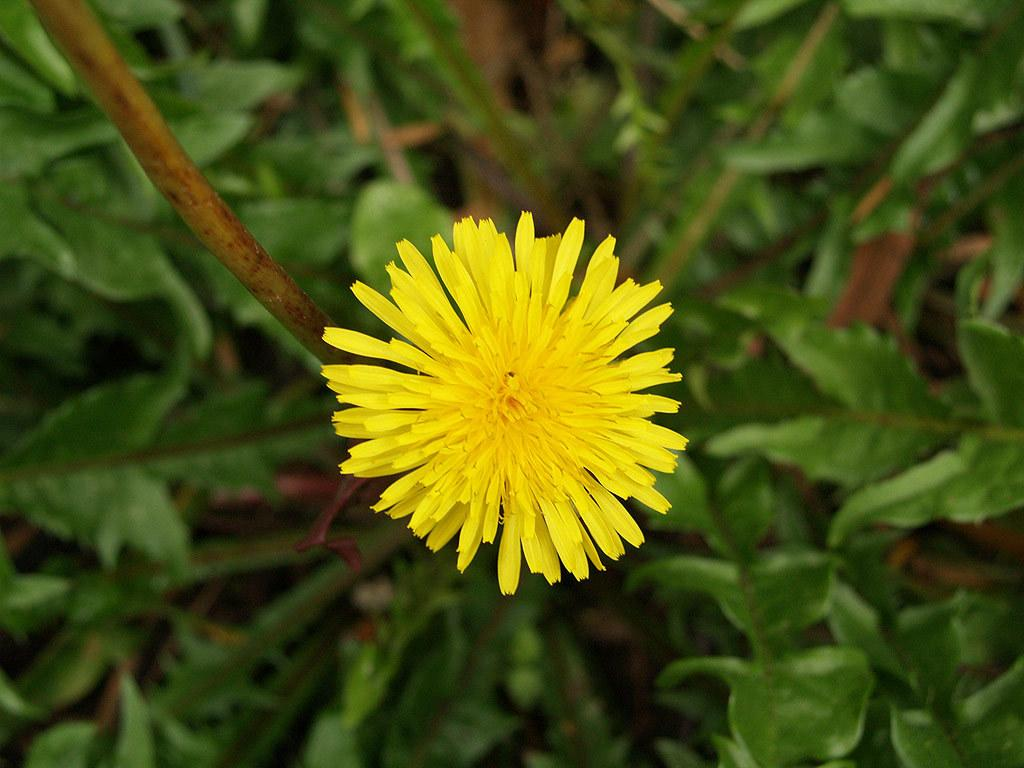What is the main subject of the image? There is a flower in the center of the image. What color is the flower? The flower is yellow. What else can be seen at the bottom of the image? There are plants at the bottom of the image. What type of bone can be seen in the image? There is no bone present in the image; it features a yellow flower and plants. Can you describe the temper of the ghost in the image? There is no ghost present in the image; it features a yellow flower and plants. 